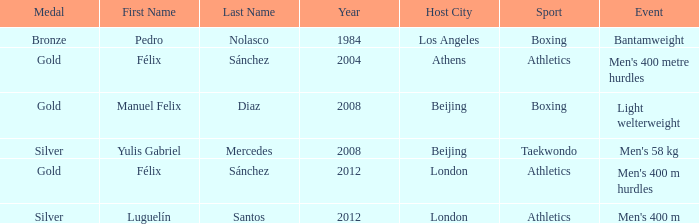What medal featured the name of manuel felix diaz? Gold. 